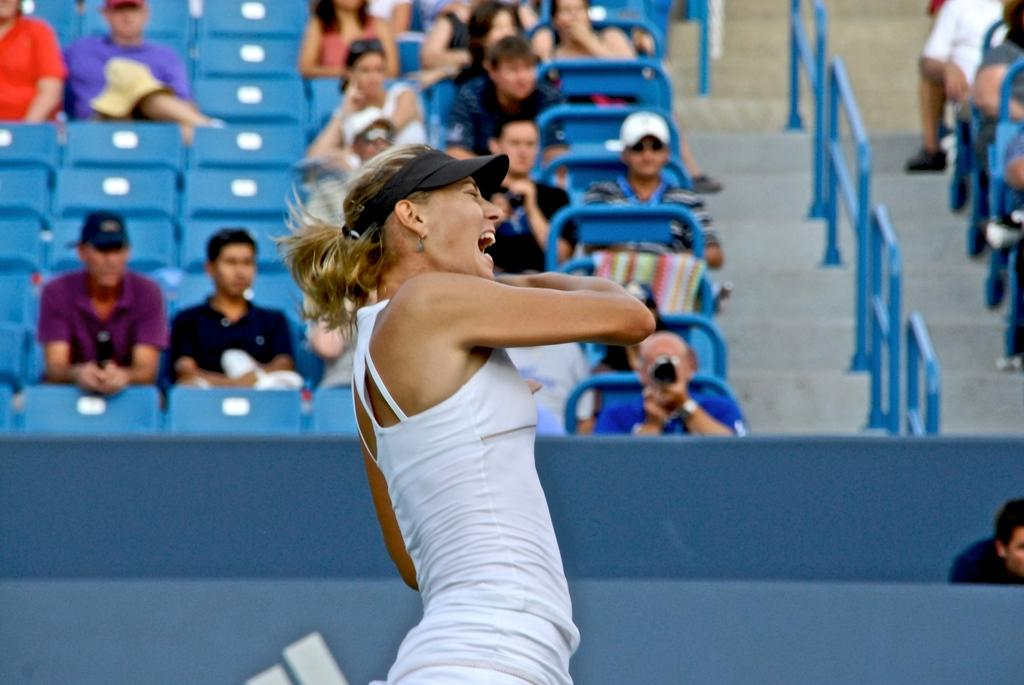What is the main subject of the image? The main subject of the image is a woman player. What is the woman player wearing on her upper body? The woman player is wearing a white top. What type of headwear is the woman player wearing? The woman player is wearing a black cap. What can be seen in the background of the image? There is a blue color stadium seat in the image. Who else is present in the image besides the woman player? There are audience members sitting on the stadium seats. What type of prose is being recited by the woman player in the image? There is no indication in the image that the woman player is reciting any prose. What color are the trousers worn by the woman player in the image? The provided facts do not mention the color of the woman player's trousers. 